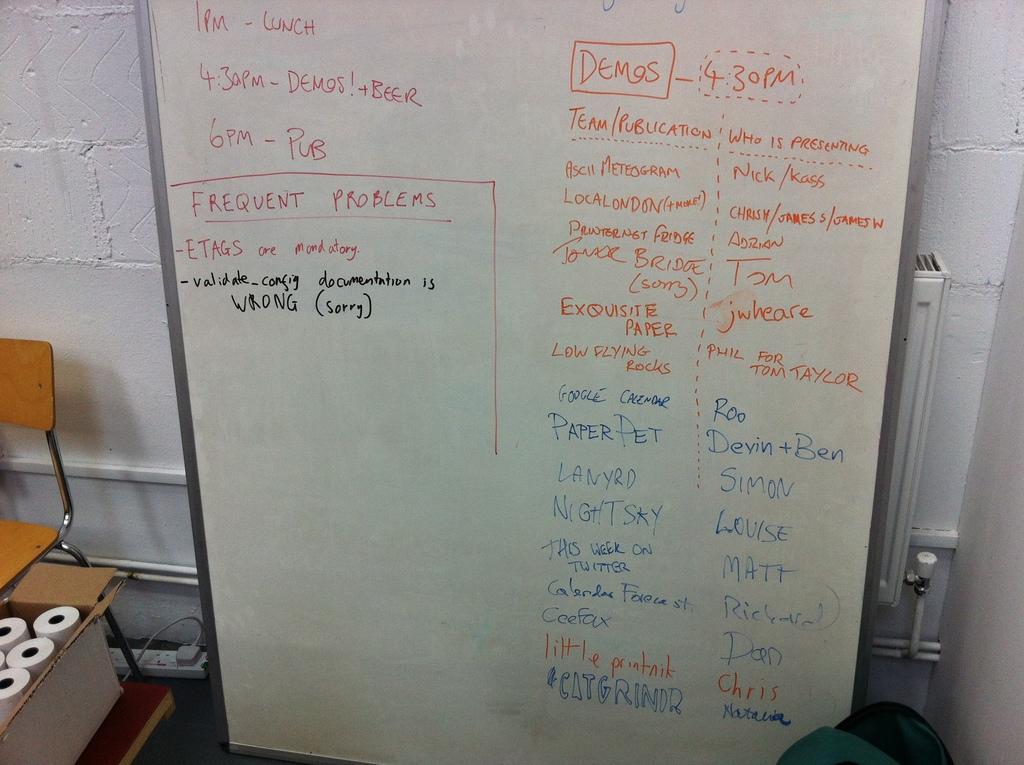What time is lunch?
Give a very brief answer. 1 pm. What time are the demos?
Your answer should be very brief. 4:30 pm. 